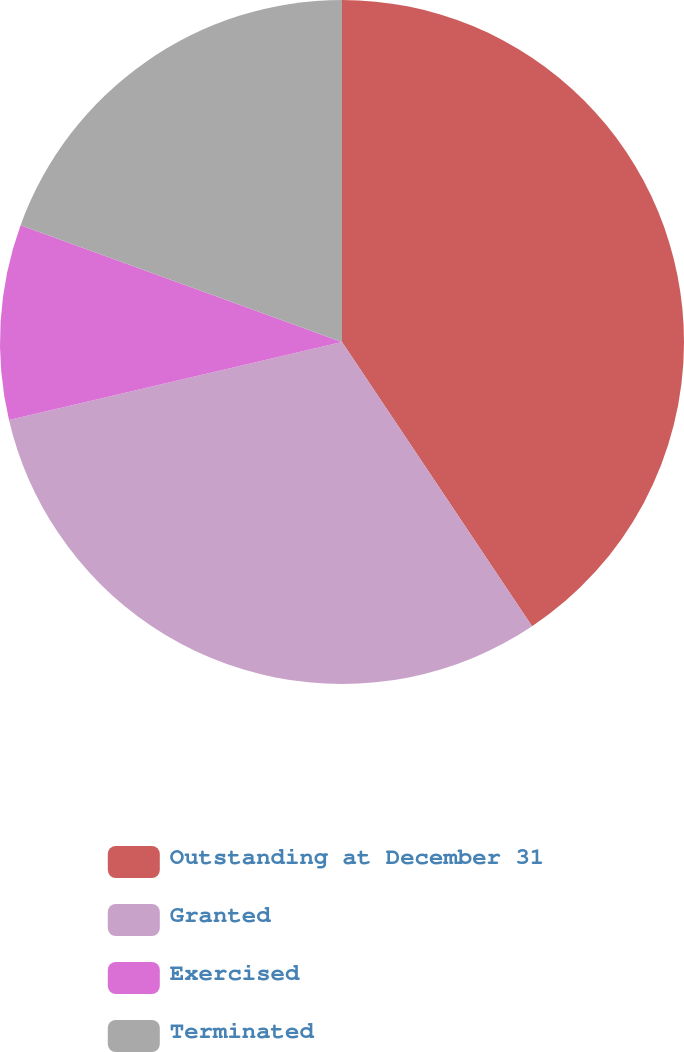<chart> <loc_0><loc_0><loc_500><loc_500><pie_chart><fcel>Outstanding at December 31<fcel>Granted<fcel>Exercised<fcel>Terminated<nl><fcel>40.62%<fcel>30.72%<fcel>9.21%<fcel>19.45%<nl></chart> 